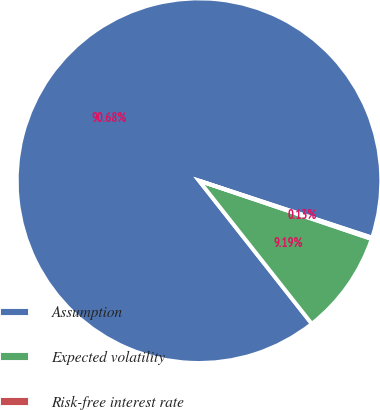Convert chart. <chart><loc_0><loc_0><loc_500><loc_500><pie_chart><fcel>Assumption<fcel>Expected volatility<fcel>Risk-free interest rate<nl><fcel>90.68%<fcel>9.19%<fcel>0.13%<nl></chart> 